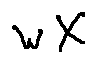<formula> <loc_0><loc_0><loc_500><loc_500>w X</formula> 